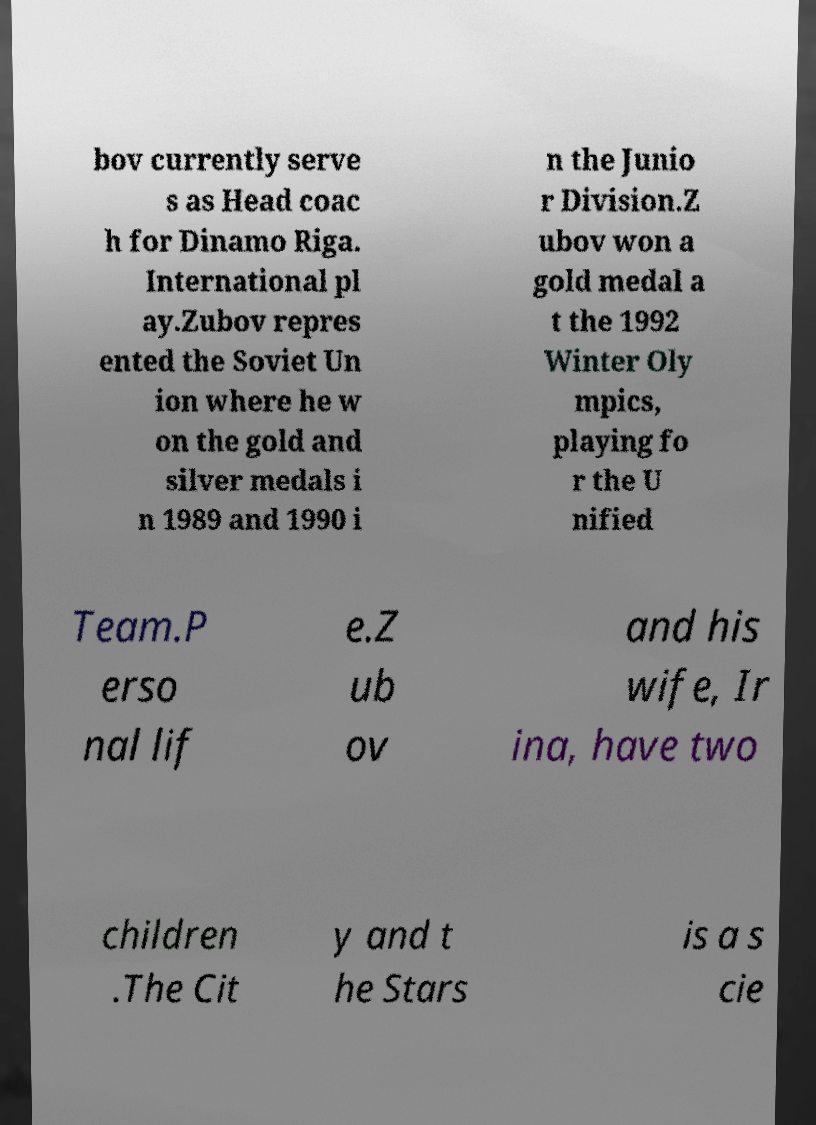For documentation purposes, I need the text within this image transcribed. Could you provide that? bov currently serve s as Head coac h for Dinamo Riga. International pl ay.Zubov repres ented the Soviet Un ion where he w on the gold and silver medals i n 1989 and 1990 i n the Junio r Division.Z ubov won a gold medal a t the 1992 Winter Oly mpics, playing fo r the U nified Team.P erso nal lif e.Z ub ov and his wife, Ir ina, have two children .The Cit y and t he Stars is a s cie 